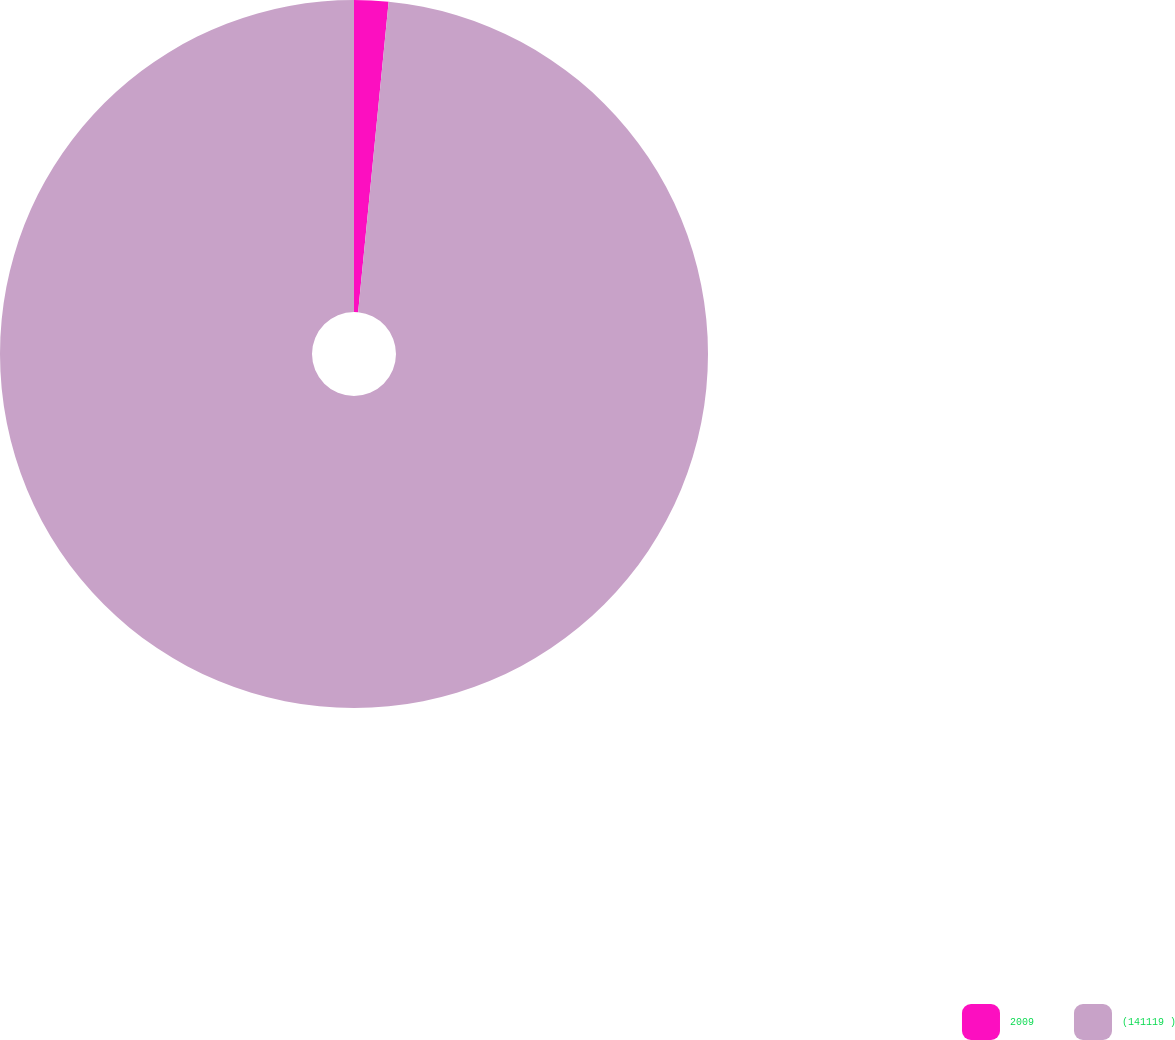Convert chart. <chart><loc_0><loc_0><loc_500><loc_500><pie_chart><fcel>2009<fcel>(141119 )<nl><fcel>1.56%<fcel>98.44%<nl></chart> 